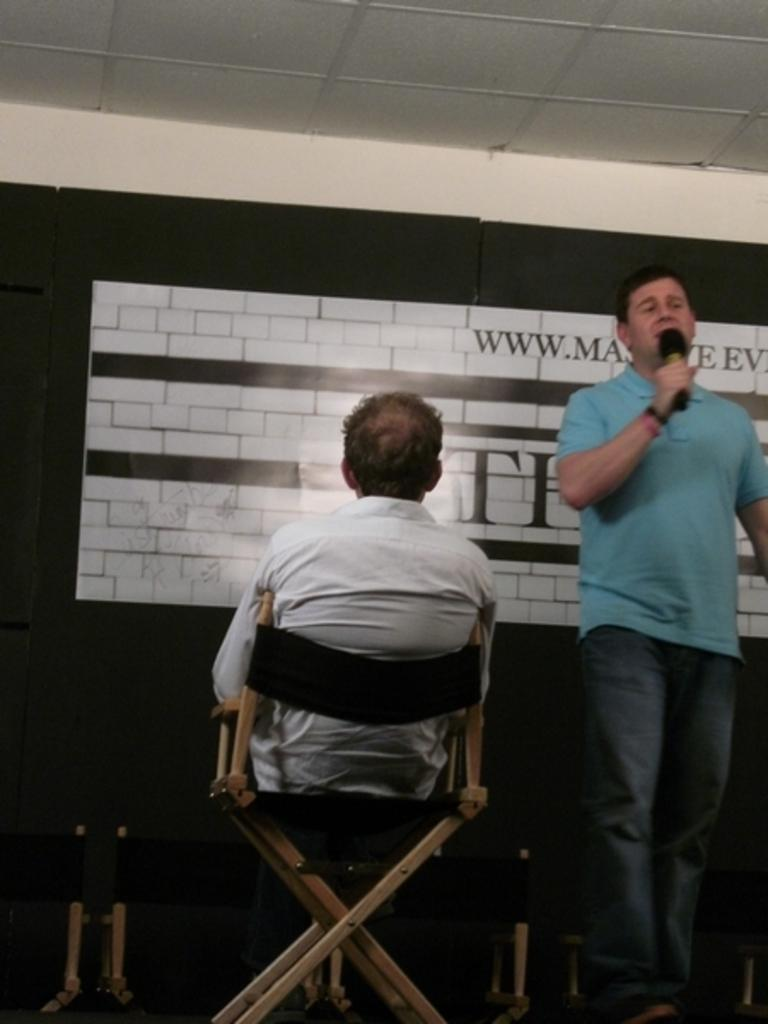How many people are in the image? There are two people in the image. Where is the person standing in the image? The standing person is on the right side of the image. What is the standing person holding? The standing person is holding a mic. What is the position of the other person in the image? The other person is sitting on a chair in the center of the image. What type of oil can be seen dripping from the person's hair in the image? There is no oil or dripping substance visible in the image. 